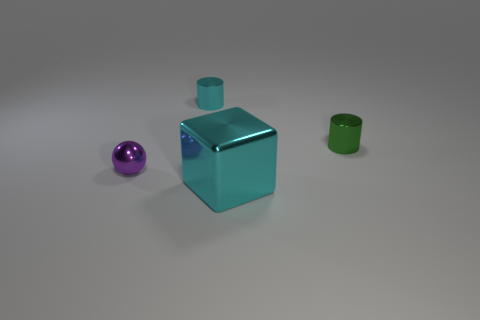Are the purple ball and the large cyan block made of the same material?
Your answer should be compact. Yes. What number of large cylinders have the same material as the cyan block?
Make the answer very short. 0. What number of objects are cyan metal things that are behind the cyan shiny cube or tiny metallic balls that are in front of the cyan cylinder?
Offer a terse response. 2. Are there more cylinders right of the tiny cyan cylinder than small metal objects that are on the left side of the small purple thing?
Offer a terse response. Yes. There is a small metallic object that is behind the green cylinder; what color is it?
Provide a short and direct response. Cyan. Are there any other objects of the same shape as the small green metallic object?
Keep it short and to the point. Yes. What number of cyan things are either tiny metal spheres or big cylinders?
Offer a terse response. 0. Is there a purple shiny thing that has the same size as the cyan shiny cylinder?
Keep it short and to the point. Yes. What number of balls are there?
Provide a succinct answer. 1. How many large objects are cyan shiny things or cyan shiny cubes?
Offer a terse response. 1. 